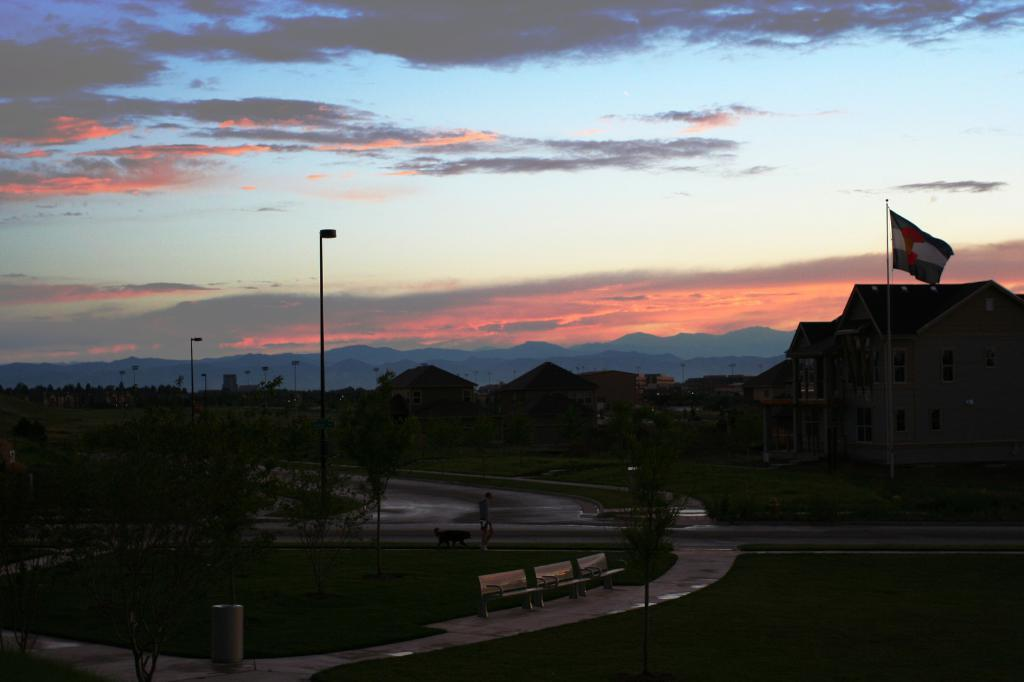What is located in the center of the image? There are buildings, poles, and trees in the center of the image. What type of seating is available at the bottom of the image? There are benches at the bottom of the image. What can be used for disposing of waste in the image? There is a bin at the bottom of the image. Who is present in the image? There is a man and a dog in the image. What can be seen in the background of the image? There are hills and sky visible in the background of the image. Can you see a balloon floating in the sky in the image? There is no balloon visible in the sky in the image. Is there an actor performing in the image? There is no actor or performance depicted in the image. 